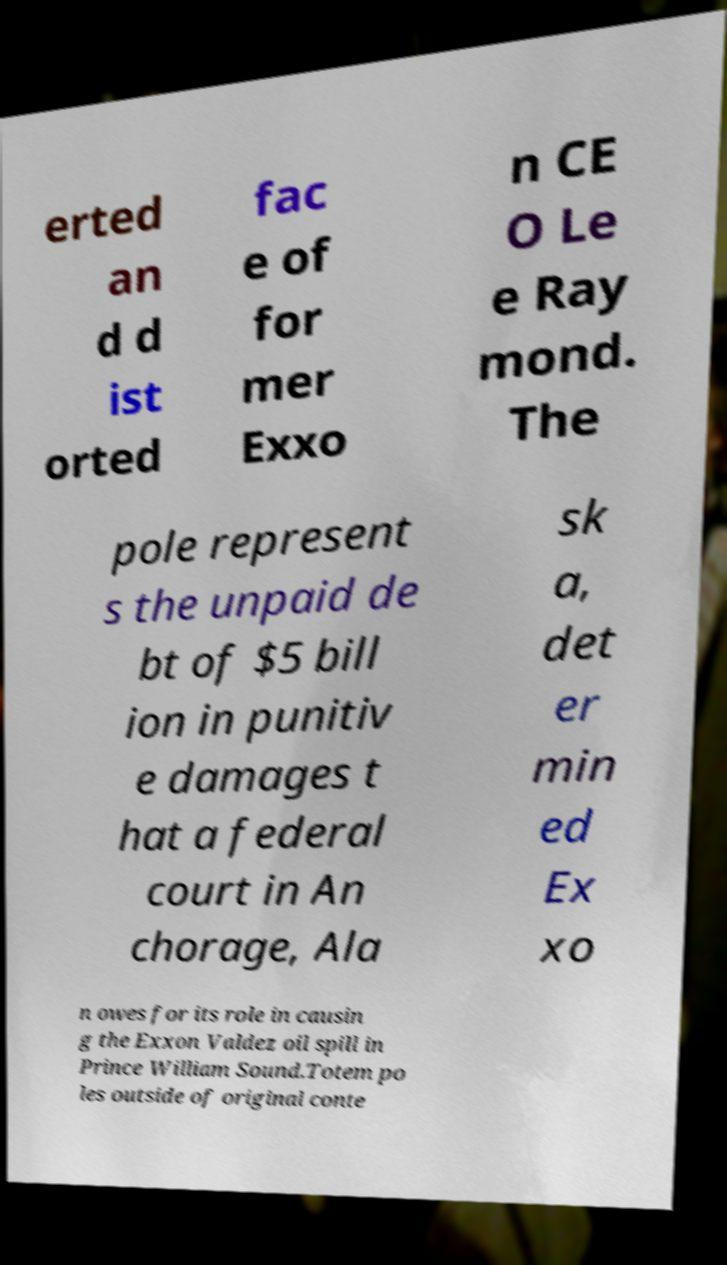Can you read and provide the text displayed in the image?This photo seems to have some interesting text. Can you extract and type it out for me? erted an d d ist orted fac e of for mer Exxo n CE O Le e Ray mond. The pole represent s the unpaid de bt of $5 bill ion in punitiv e damages t hat a federal court in An chorage, Ala sk a, det er min ed Ex xo n owes for its role in causin g the Exxon Valdez oil spill in Prince William Sound.Totem po les outside of original conte 